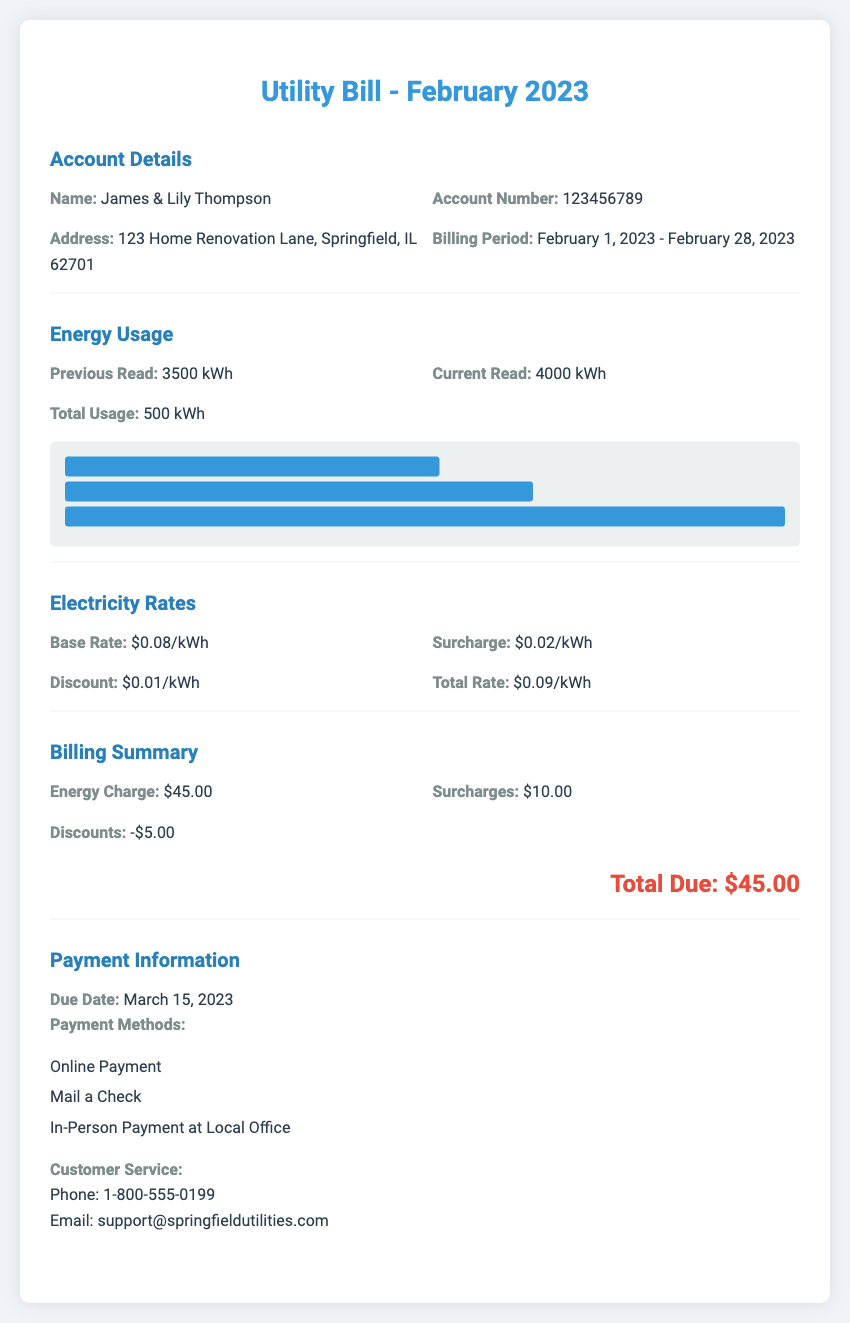what is the name on the account? The name on the account is provided in the account details section.
Answer: James & Lily Thompson what is the account number? The account number is listed under the account details section.
Answer: 123456789 what is the billing period? The billing period indicates the time frame for which the bill is calculated, mentioned in the account details section.
Answer: February 1, 2023 - February 28, 2023 how much total energy was used? The total energy usage is calculated by subtracting the previous read from the current read, as stated in the energy usage section.
Answer: 500 kWh what is the total rate per kWh? The total rate is provided under the electricity rates section by summing the base rate, surcharge, and discount.
Answer: $0.09/kWh what is the energy charge? The energy charge is detailed in the billing summary section and reflects the cost of the energy used.
Answer: $45.00 what is the total amount due? The total amount due is listed in the billing summary section as the final amount to be paid.
Answer: $45.00 when is the due date? The due date for the payment is mentioned under the payment information section.
Answer: March 15, 2023 which payment methods are available? The available payment methods are listed in the payment information section and specify the ways to pay the bill.
Answer: Online Payment, Mail a Check, In-Person Payment at Local Office 